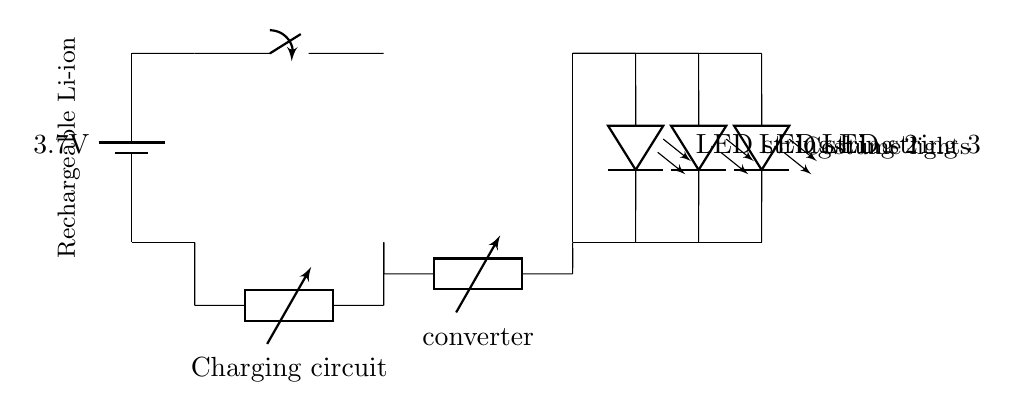What is the voltage of the battery? The battery in the circuit is labeled as having a voltage of 3.7 volts. This can be found directly on the battery component in the circuit diagram.
Answer: 3.7 volts What type of circuit is used for charging? The charging circuit is indicated as a USB charging circuit. This is shown as a generic charging component labeled 'Charging circuit' connected to the battery.
Answer: USB How many LED strings are in the circuit? There are three LED strings shown in the circuit diagram, each labeled as 'LED string 1', 'LED string 2', and 'LED string 3'. The connections from the boost converter lead to each LED string separately.
Answer: Three What is the function of the boost converter? The boost converter's function is to step up the voltage output from the battery to a higher level suitable for powering the LED strings. This is indicated by its label 'Boost converter' in the circuit diagram.
Answer: Step-up voltage What component is used to turn the lights on or off? A switch is indicated in the circuit diagram, allowing the user to control the flow of power to the LED strings by opening or closing the circuit. The component is marked as 'switch'.
Answer: Switch What is the main power source for the circuit? The main power source is a rechargeable lithium-ion battery. This is explicit from the labeling near the battery component in the circuit.
Answer: Rechargeable lithium-ion battery 